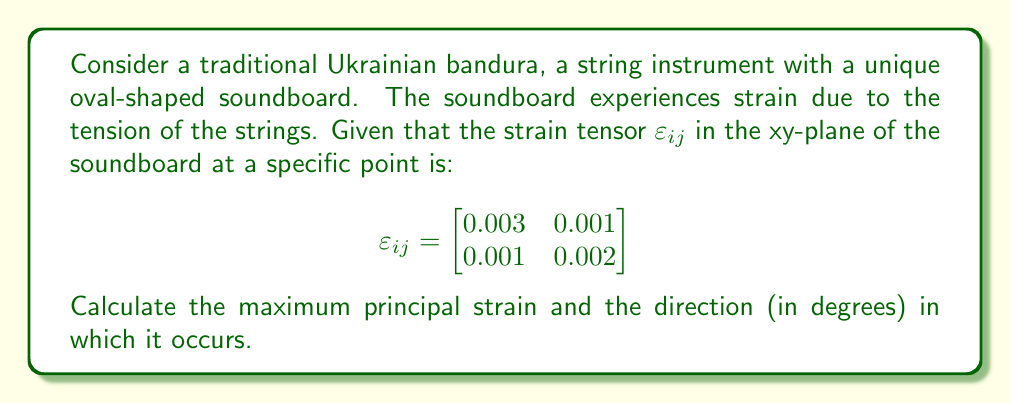Help me with this question. To find the maximum principal strain and its direction, we need to follow these steps:

1) The principal strains are the eigenvalues of the strain tensor. To find them, we solve the characteristic equation:

   $$det(\varepsilon_{ij} - \lambda I) = 0$$

2) Expanding this:

   $$\begin{vmatrix}
   0.003 - \lambda & 0.001 \\
   0.001 & 0.002 - \lambda
   \end{vmatrix} = 0$$

3) This gives us the quadratic equation:

   $$(0.003 - \lambda)(0.002 - \lambda) - (0.001)^2 = 0$$
   $$\lambda^2 - 0.005\lambda + 0.000005 = 0$$

4) Solving this quadratic equation:

   $$\lambda = \frac{0.005 \pm \sqrt{0.005^2 - 4(0.000005)}}{2}$$
   $$\lambda = \frac{0.005 \pm \sqrt{0.000025 - 0.00002}}{2}$$
   $$\lambda = \frac{0.005 \pm \sqrt{0.000005}}{2}$$
   $$\lambda = \frac{0.005 \pm 0.002236}{2}$$

5) This gives us two principal strains:

   $$\lambda_1 = 0.003618 \text{ (maximum)}$$
   $$\lambda_2 = 0.001382 \text{ (minimum)}$$

6) To find the direction of the maximum principal strain, we use the formula:

   $$\tan 2\theta = \frac{2\varepsilon_{xy}}{\varepsilon_{xx} - \varepsilon_{yy}}$$

7) Substituting the values:

   $$\tan 2\theta = \frac{2(0.001)}{0.003 - 0.002} = 2$$

8) Solving for $\theta$:

   $$2\theta = \arctan(2) = 1.107148 \text{ radians}$$
   $$\theta = 0.553574 \text{ radians} = 31.72^\circ$$

Therefore, the maximum principal strain is 0.003618, and it occurs at an angle of 31.72° from the x-axis.
Answer: 0.003618, 31.72° 